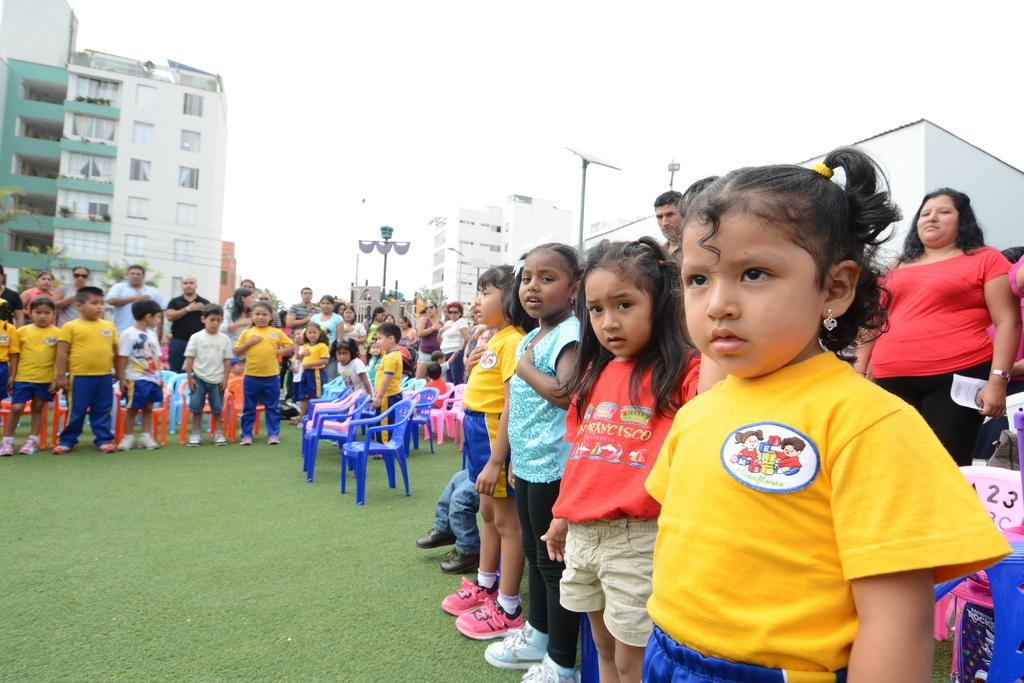How many people are in the image? There is a group of persons standing in the image. What is located in the center of the image? There are empty chairs in the center of the image. What type of surface is the group of persons standing on? There is grass on the ground. What can be seen in the background of the image? There are buildings and poles in the background of the image. How many ants can be seen crawling on the cannon in the image? There is no cannon present in the image, and therefore no ants can be seen crawling on it. 